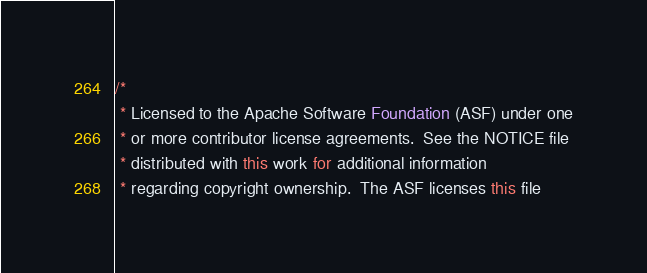Convert code to text. <code><loc_0><loc_0><loc_500><loc_500><_Java_>/*
 * Licensed to the Apache Software Foundation (ASF) under one
 * or more contributor license agreements.  See the NOTICE file
 * distributed with this work for additional information
 * regarding copyright ownership.  The ASF licenses this file</code> 